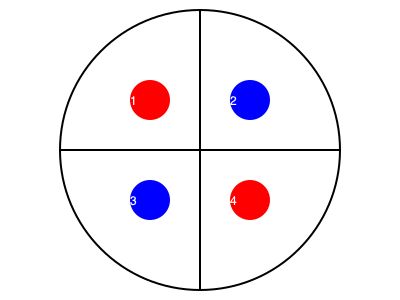During metaphase of mitosis, homologous chromosomes align at the equatorial plane. If the diagram represents a cell with two pairs of homologous chromosomes (red and blue), which of the following arrangements correctly represents the metaphase plate? To solve this problem, we need to understand the key characteristics of metaphase in mitosis:

1. In metaphase of mitosis, chromosomes align at the equatorial plane (metaphase plate).
2. Each chromosome consists of two sister chromatids.
3. Homologous chromosomes do not pair up in mitosis (unlike in meiosis).

Analyzing the diagram:
- The circle represents the cell.
- The horizontal line represents the equatorial plane or metaphase plate.
- Red and blue circles represent different chromosomes.

Steps to determine the correct arrangement:
1. Identify homologous pairs: Red chromosomes are homologous, and blue chromosomes are homologous.
2. In metaphase of mitosis, each chromosome (consisting of two sister chromatids) should be aligned at the equatorial plane.
3. Homologous chromosomes can be on either side of the equatorial plane, but sister chromatids must be together.

Looking at the numbered positions:
- 1 and 4 are red chromosomes (homologous pair)
- 2 and 3 are blue chromosomes (homologous pair)

The correct arrangement would have one red and one blue chromosome on each side of the equatorial plane. This corresponds to the current arrangement in the diagram: (1,2) on top and (3,4) on bottom.
Answer: 1,2 - 3,4 